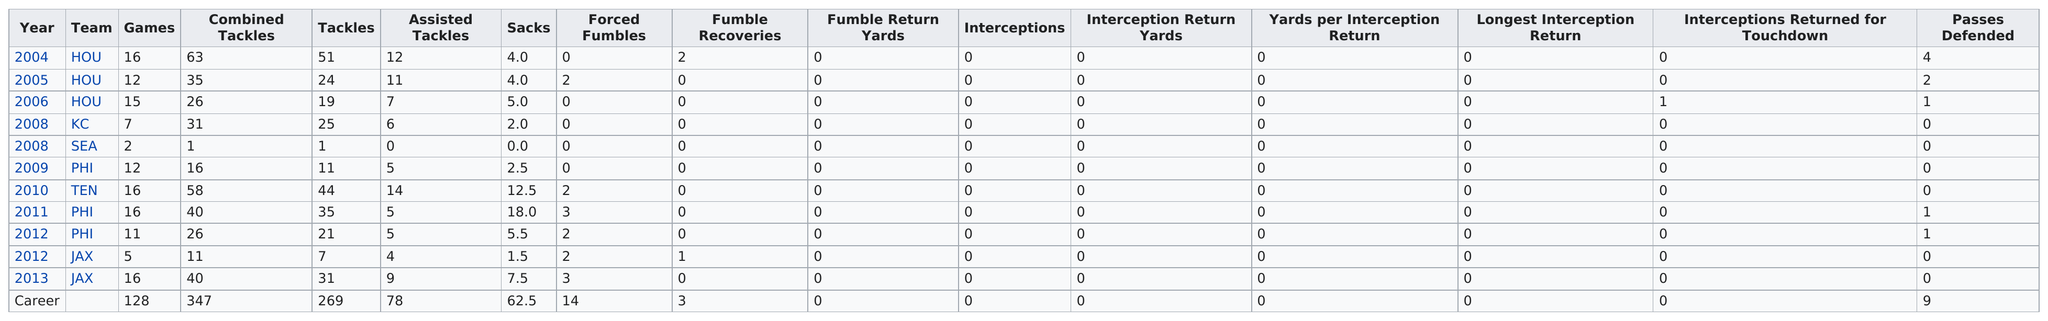Mention a couple of crucial points in this snapshot. Babin played for 7 different teams throughout his career. I have been informed that the total amount of sacks recorded for Houston is 13. Babin had 5 sacks in 2006. In the year 2008, Babin recorded the fewest tackles out of all the seasons he played. While playing for the Philadelphia team, I accumulated a total of 26 sacks. 